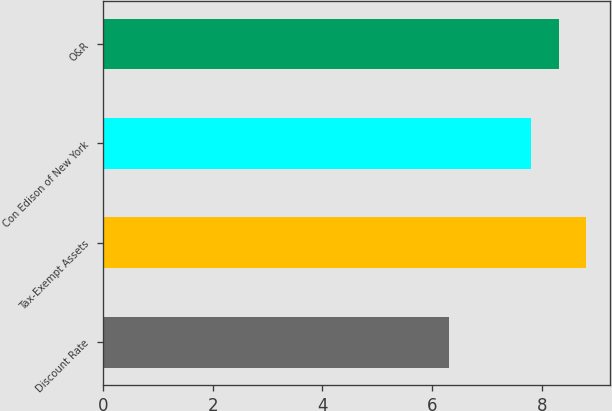Convert chart. <chart><loc_0><loc_0><loc_500><loc_500><bar_chart><fcel>Discount Rate<fcel>Tax-Exempt Assets<fcel>Con Edison of New York<fcel>O&R<nl><fcel>6.3<fcel>8.8<fcel>7.8<fcel>8.3<nl></chart> 